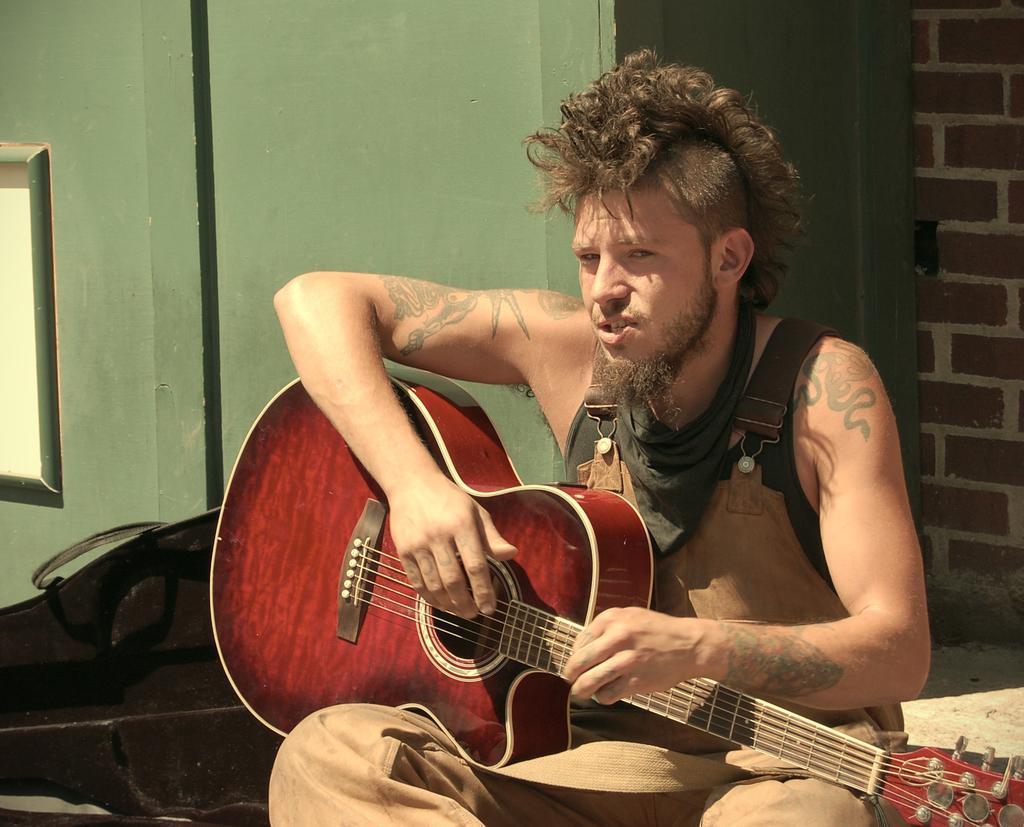Describe this image in one or two sentences. In a picture there is a one person sitting and holding a guitar, he is wearing a jumpsuit behind him there is a brick wall and a green colour wall, beside him there is a guitar bag. The person has tattoos on his body. 